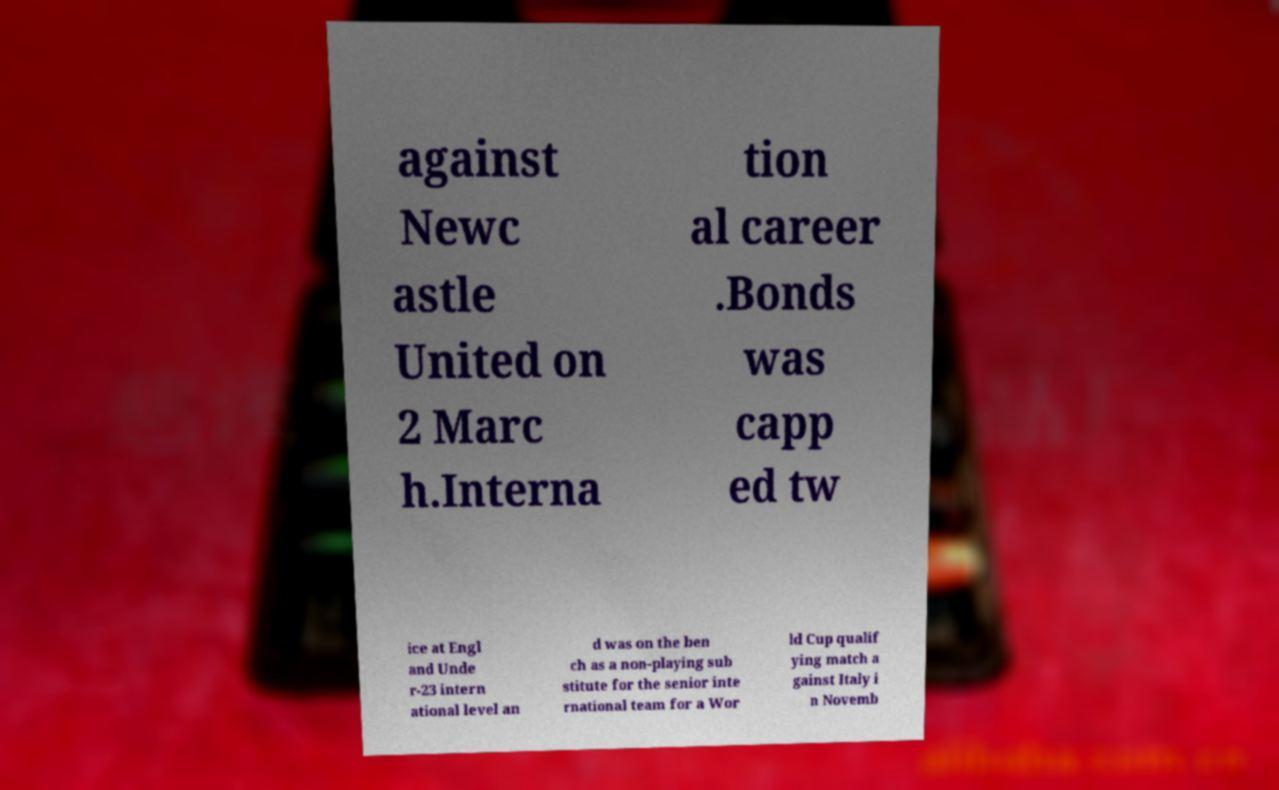There's text embedded in this image that I need extracted. Can you transcribe it verbatim? against Newc astle United on 2 Marc h.Interna tion al career .Bonds was capp ed tw ice at Engl and Unde r-23 intern ational level an d was on the ben ch as a non-playing sub stitute for the senior inte rnational team for a Wor ld Cup qualif ying match a gainst Italy i n Novemb 